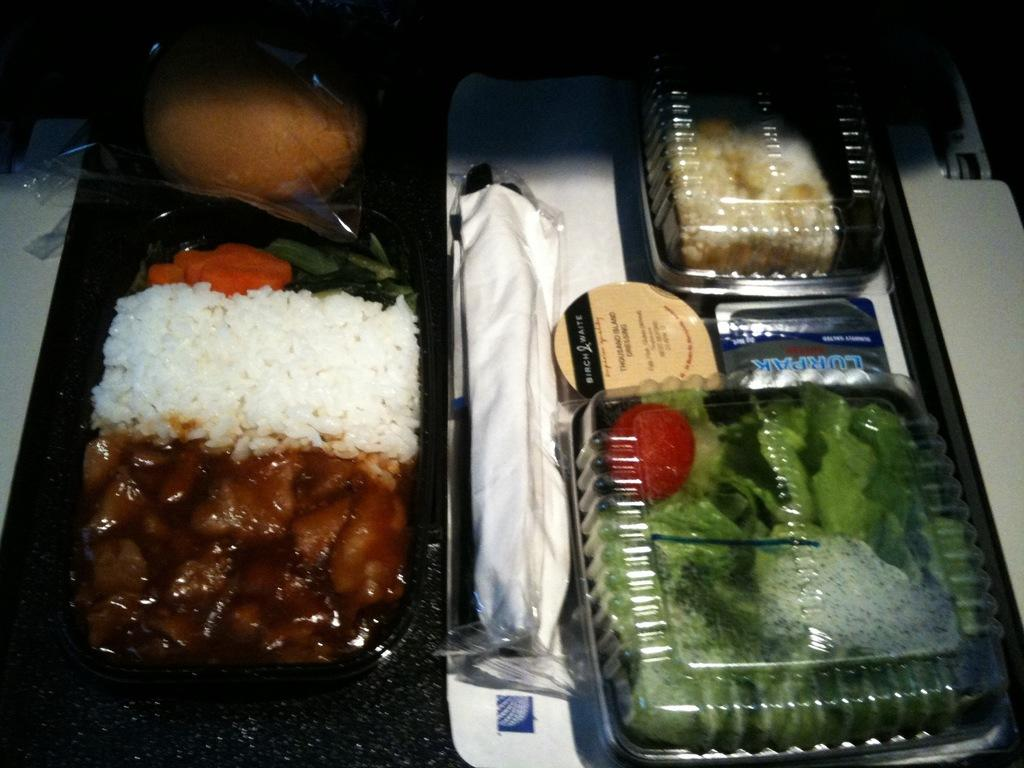<image>
Write a terse but informative summary of the picture. three black plastic boxes with food in them, along with a small container of birch and waite thousand island dressing 